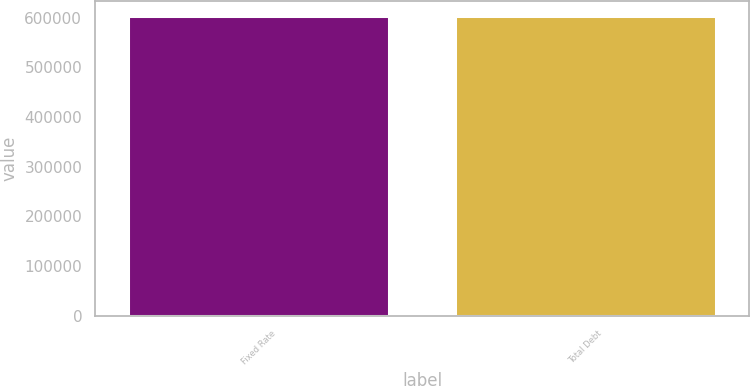<chart> <loc_0><loc_0><loc_500><loc_500><bar_chart><fcel>Fixed Rate<fcel>Total Debt<nl><fcel>603303<fcel>603303<nl></chart> 